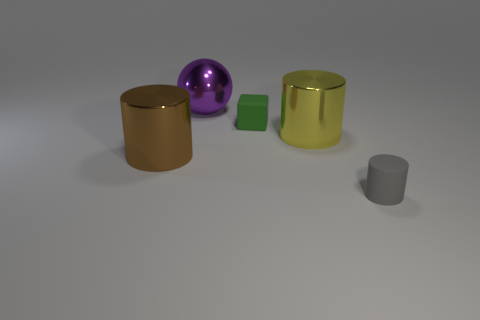There is a metallic cylinder on the left side of the big cylinder behind the cylinder on the left side of the purple shiny thing; what is its color?
Give a very brief answer. Brown. The thing that is both behind the yellow metal cylinder and to the left of the rubber block has what shape?
Your answer should be very brief. Sphere. Are there any other things that are the same size as the gray matte cylinder?
Keep it short and to the point. Yes. What color is the shiny thing that is behind the rubber object behind the tiny gray matte cylinder?
Provide a succinct answer. Purple. There is a tiny matte thing behind the matte thing to the right of the large cylinder on the right side of the green object; what is its shape?
Ensure brevity in your answer.  Cube. What size is the cylinder that is on the left side of the small gray rubber thing and on the right side of the shiny sphere?
Ensure brevity in your answer.  Large. How many tiny matte objects are the same color as the small rubber cylinder?
Make the answer very short. 0. What is the purple ball made of?
Make the answer very short. Metal. Does the tiny thing behind the tiny gray matte object have the same material as the small cylinder?
Your answer should be compact. Yes. There is a large object on the right side of the big metal ball; what is its shape?
Ensure brevity in your answer.  Cylinder. 